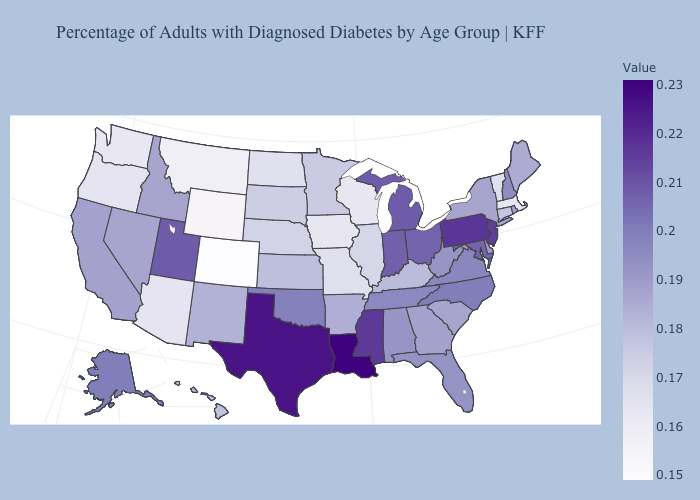Which states have the highest value in the USA?
Short answer required. Louisiana. Does Colorado have the lowest value in the USA?
Write a very short answer. Yes. Among the states that border Iowa , does Minnesota have the highest value?
Quick response, please. Yes. Which states have the lowest value in the USA?
Quick response, please. Colorado. Among the states that border New Hampshire , which have the lowest value?
Short answer required. Massachusetts. Does the map have missing data?
Give a very brief answer. No. 